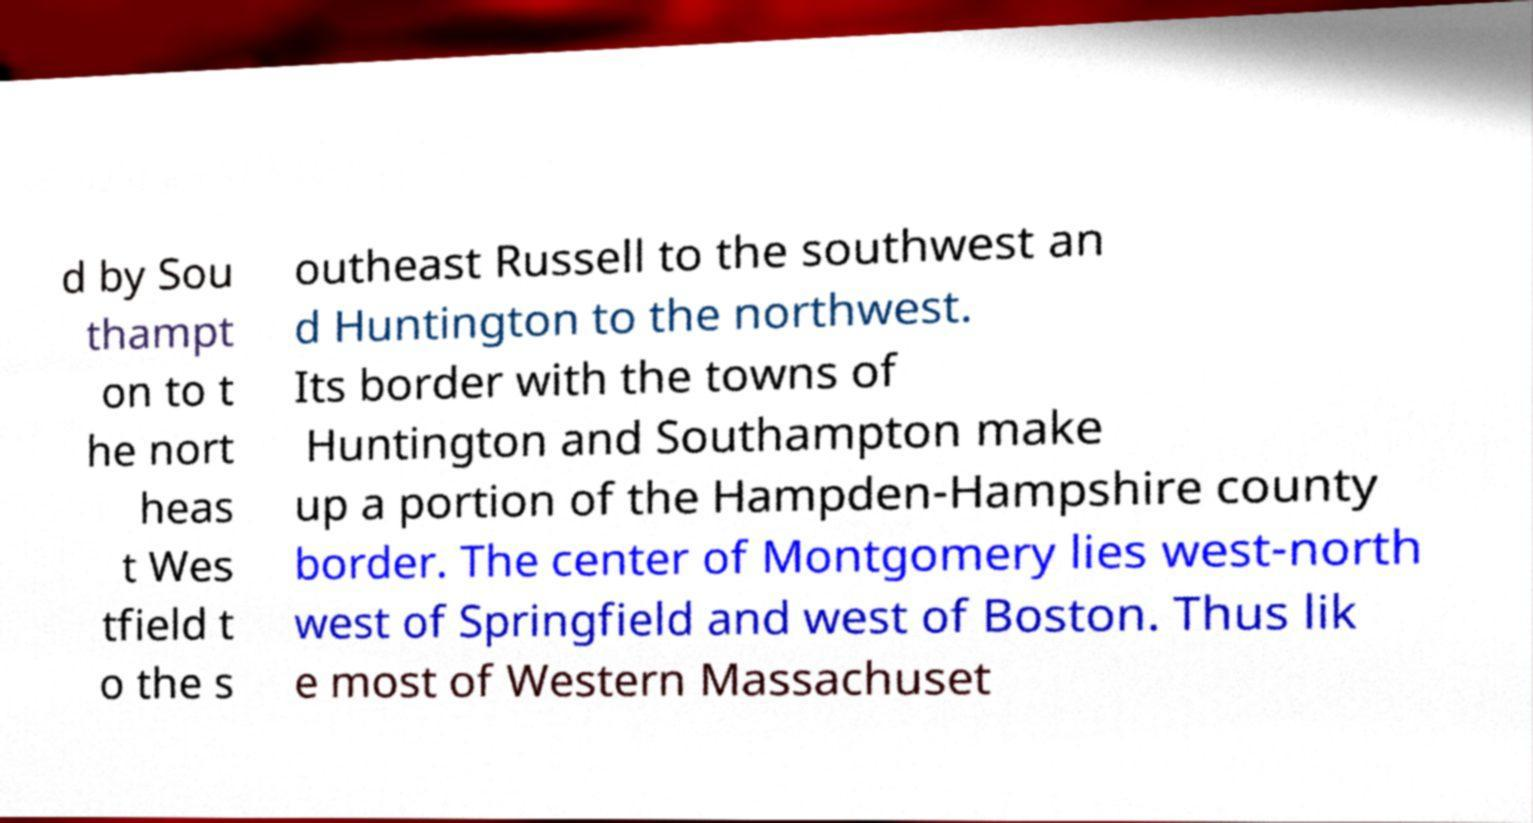Please identify and transcribe the text found in this image. d by Sou thampt on to t he nort heas t Wes tfield t o the s outheast Russell to the southwest an d Huntington to the northwest. Its border with the towns of Huntington and Southampton make up a portion of the Hampden-Hampshire county border. The center of Montgomery lies west-north west of Springfield and west of Boston. Thus lik e most of Western Massachuset 